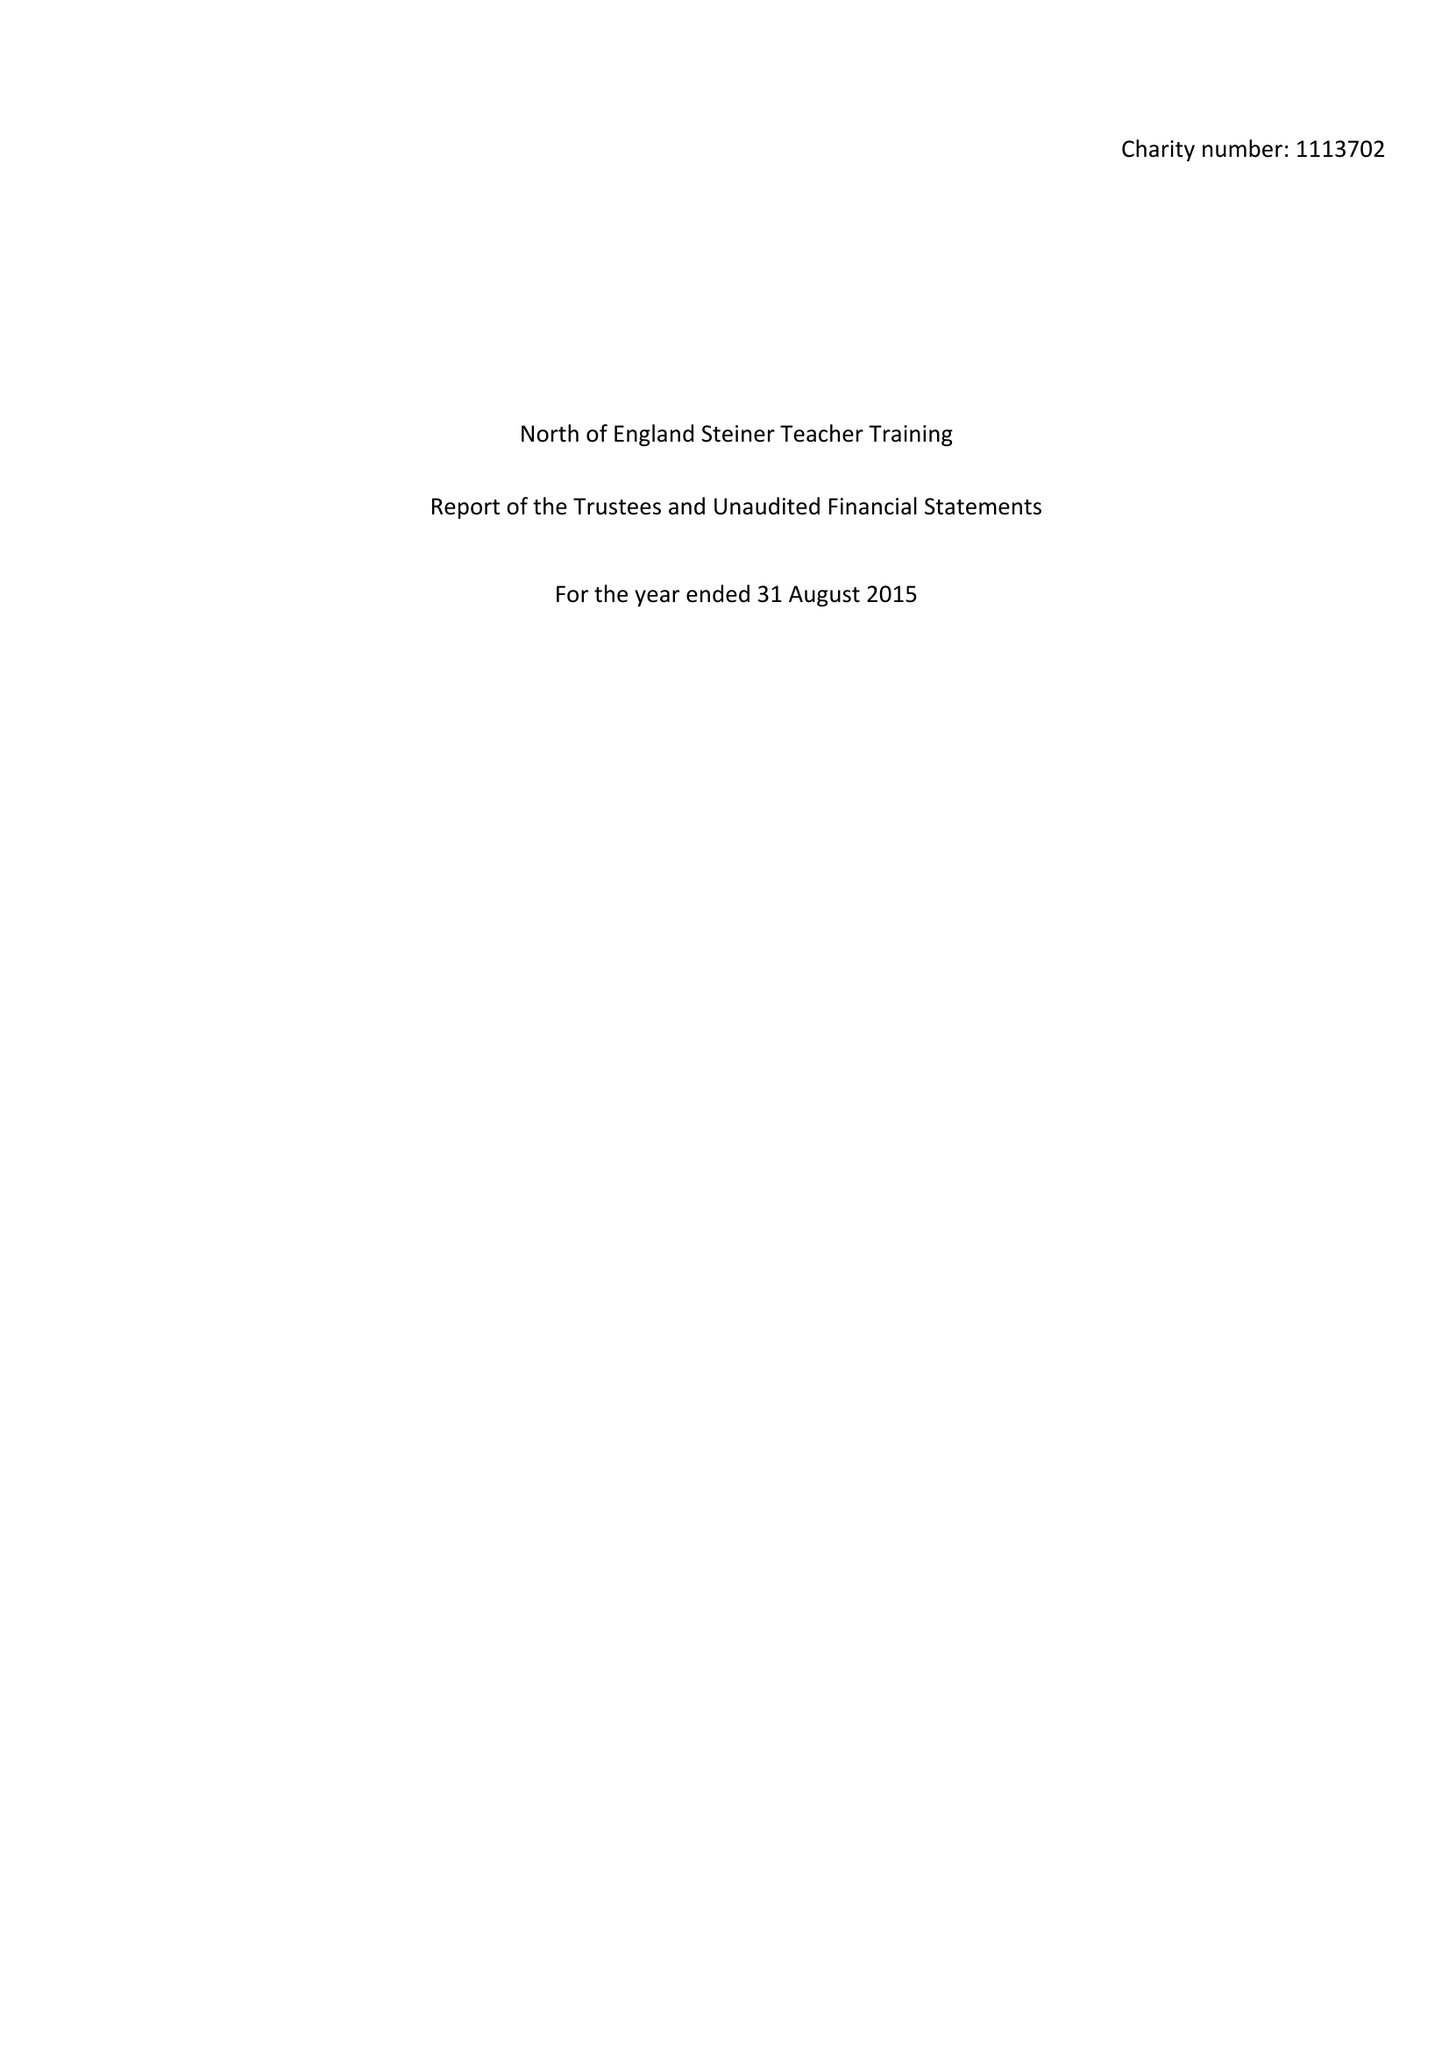What is the value for the address__street_line?
Answer the question using a single word or phrase. 15 SCHOOL LANE 